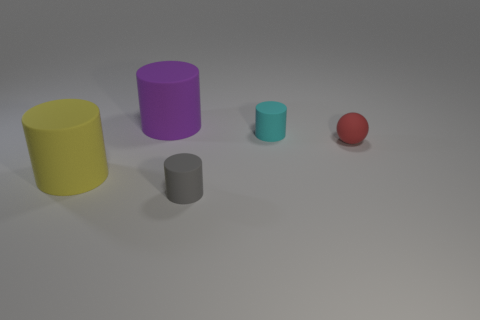Subtract 1 cylinders. How many cylinders are left? 3 Add 1 big yellow rubber cylinders. How many objects exist? 6 Subtract all cylinders. How many objects are left? 1 Add 5 big cylinders. How many big cylinders are left? 7 Add 2 tiny cyan rubber things. How many tiny cyan rubber things exist? 3 Subtract 0 green cylinders. How many objects are left? 5 Subtract all tiny gray matte cylinders. Subtract all large yellow rubber objects. How many objects are left? 3 